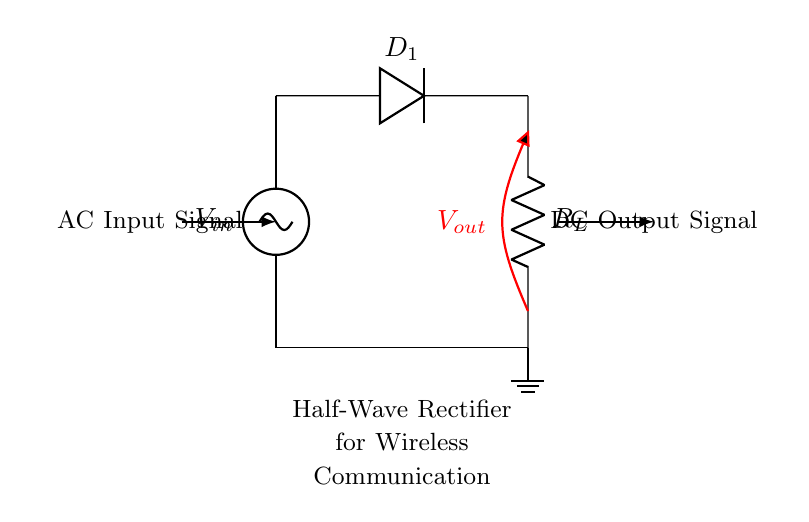What type of diode is used in this circuit? The circuit diagram shows a diode labeled D_1, indicating that a standard diode is being used for rectification.
Answer: standard diode What is the function of the resistor in this circuit? The resistor labeled R_L is connected to the output of the diode and provides a load for the rectified output voltage, allowing current to flow through the circuit.
Answer: load What is the output voltage of the half-wave rectifier when the input is positive? During the positive half cycle of the input AC signal, the diode conducts, allowing the output voltage to follow the input voltage closely.
Answer: equal to input Which direction does the current flow when the diode is conducting? Current flows from the anode to the cathode of the diode, which means it flows from the AC source through the diode to the load resistor.
Answer: anode to cathode Explain why the output signal is considered unidirectional. The half-wave rectifier allows current to flow only during one half-cycle of the AC input, blocking the negative half-cycle due to the diode's orientation, resulting in a unidirectional output signal.
Answer: one direction only What type of rectifier circuit is represented in the diagram? The circuit is a half-wave rectifier, which only rectifies one half of the AC signal due to the diode's properties, resulting in a pulsating DC output.
Answer: half-wave rectifier What happens to the AC voltage during the negative half cycle? During the negative half cycle, the diode becomes reverse-biased, preventing current from flowing through the circuit, leading to zero output voltage during this period.
Answer: zero output 